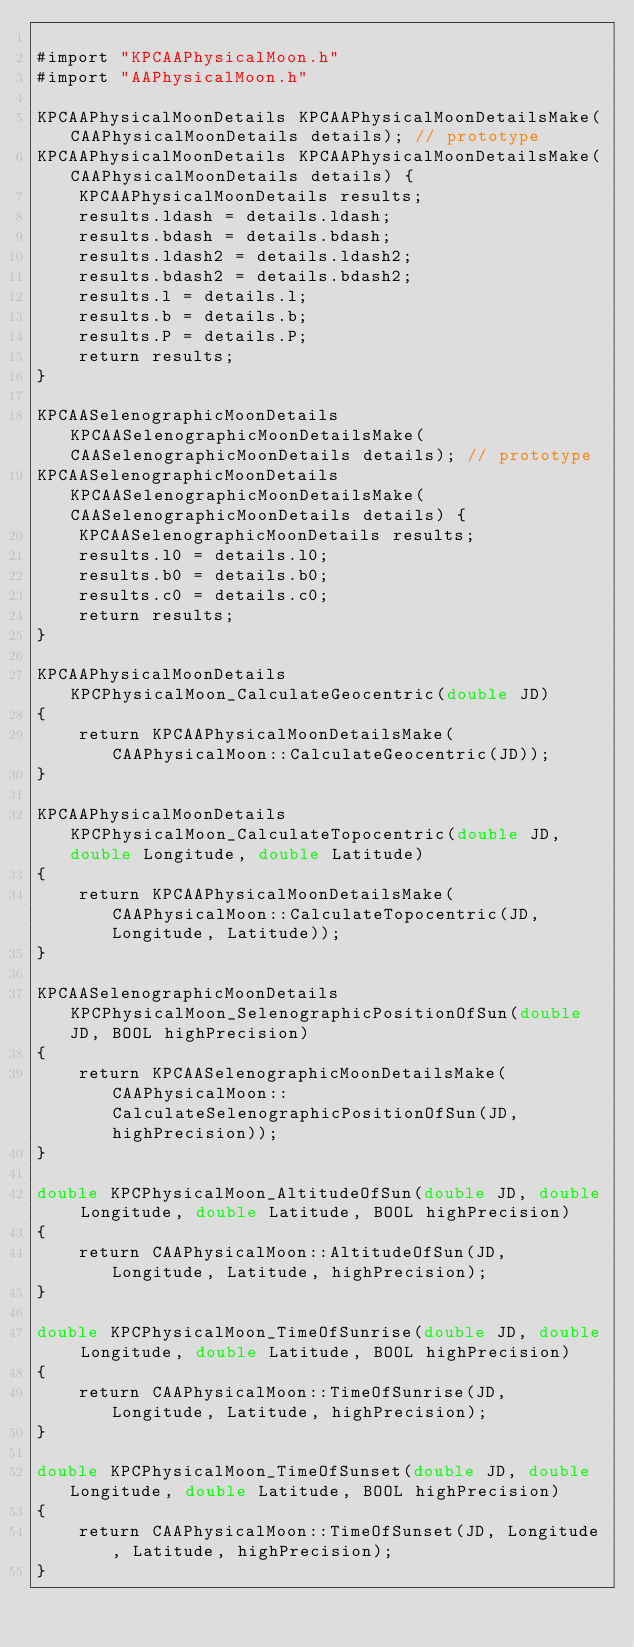<code> <loc_0><loc_0><loc_500><loc_500><_ObjectiveC_>
#import "KPCAAPhysicalMoon.h"
#import "AAPhysicalMoon.h"

KPCAAPhysicalMoonDetails KPCAAPhysicalMoonDetailsMake(CAAPhysicalMoonDetails details); // prototype
KPCAAPhysicalMoonDetails KPCAAPhysicalMoonDetailsMake(CAAPhysicalMoonDetails details) {
    KPCAAPhysicalMoonDetails results;
    results.ldash = details.ldash;
    results.bdash = details.bdash;
    results.ldash2 = details.ldash2;
    results.bdash2 = details.bdash2;
    results.l = details.l;
    results.b = details.b;
    results.P = details.P;
    return results;
}

KPCAASelenographicMoonDetails KPCAASelenographicMoonDetailsMake(CAASelenographicMoonDetails details); // prototype
KPCAASelenographicMoonDetails KPCAASelenographicMoonDetailsMake(CAASelenographicMoonDetails details) {
    KPCAASelenographicMoonDetails results;
    results.l0 = details.l0;
    results.b0 = details.b0;
    results.c0 = details.c0;
    return results;
}

KPCAAPhysicalMoonDetails KPCPhysicalMoon_CalculateGeocentric(double JD)
{
    return KPCAAPhysicalMoonDetailsMake(CAAPhysicalMoon::CalculateGeocentric(JD));
}

KPCAAPhysicalMoonDetails KPCPhysicalMoon_CalculateTopocentric(double JD, double Longitude, double Latitude)
{
    return KPCAAPhysicalMoonDetailsMake(CAAPhysicalMoon::CalculateTopocentric(JD, Longitude, Latitude));
}

KPCAASelenographicMoonDetails KPCPhysicalMoon_SelenographicPositionOfSun(double JD, BOOL highPrecision)
{
    return KPCAASelenographicMoonDetailsMake(CAAPhysicalMoon::CalculateSelenographicPositionOfSun(JD, highPrecision));
}

double KPCPhysicalMoon_AltitudeOfSun(double JD, double Longitude, double Latitude, BOOL highPrecision)
{
    return CAAPhysicalMoon::AltitudeOfSun(JD, Longitude, Latitude, highPrecision);
}

double KPCPhysicalMoon_TimeOfSunrise(double JD, double Longitude, double Latitude, BOOL highPrecision)
{
    return CAAPhysicalMoon::TimeOfSunrise(JD, Longitude, Latitude, highPrecision);
}

double KPCPhysicalMoon_TimeOfSunset(double JD, double Longitude, double Latitude, BOOL highPrecision)
{
    return CAAPhysicalMoon::TimeOfSunset(JD, Longitude, Latitude, highPrecision);
}

</code> 